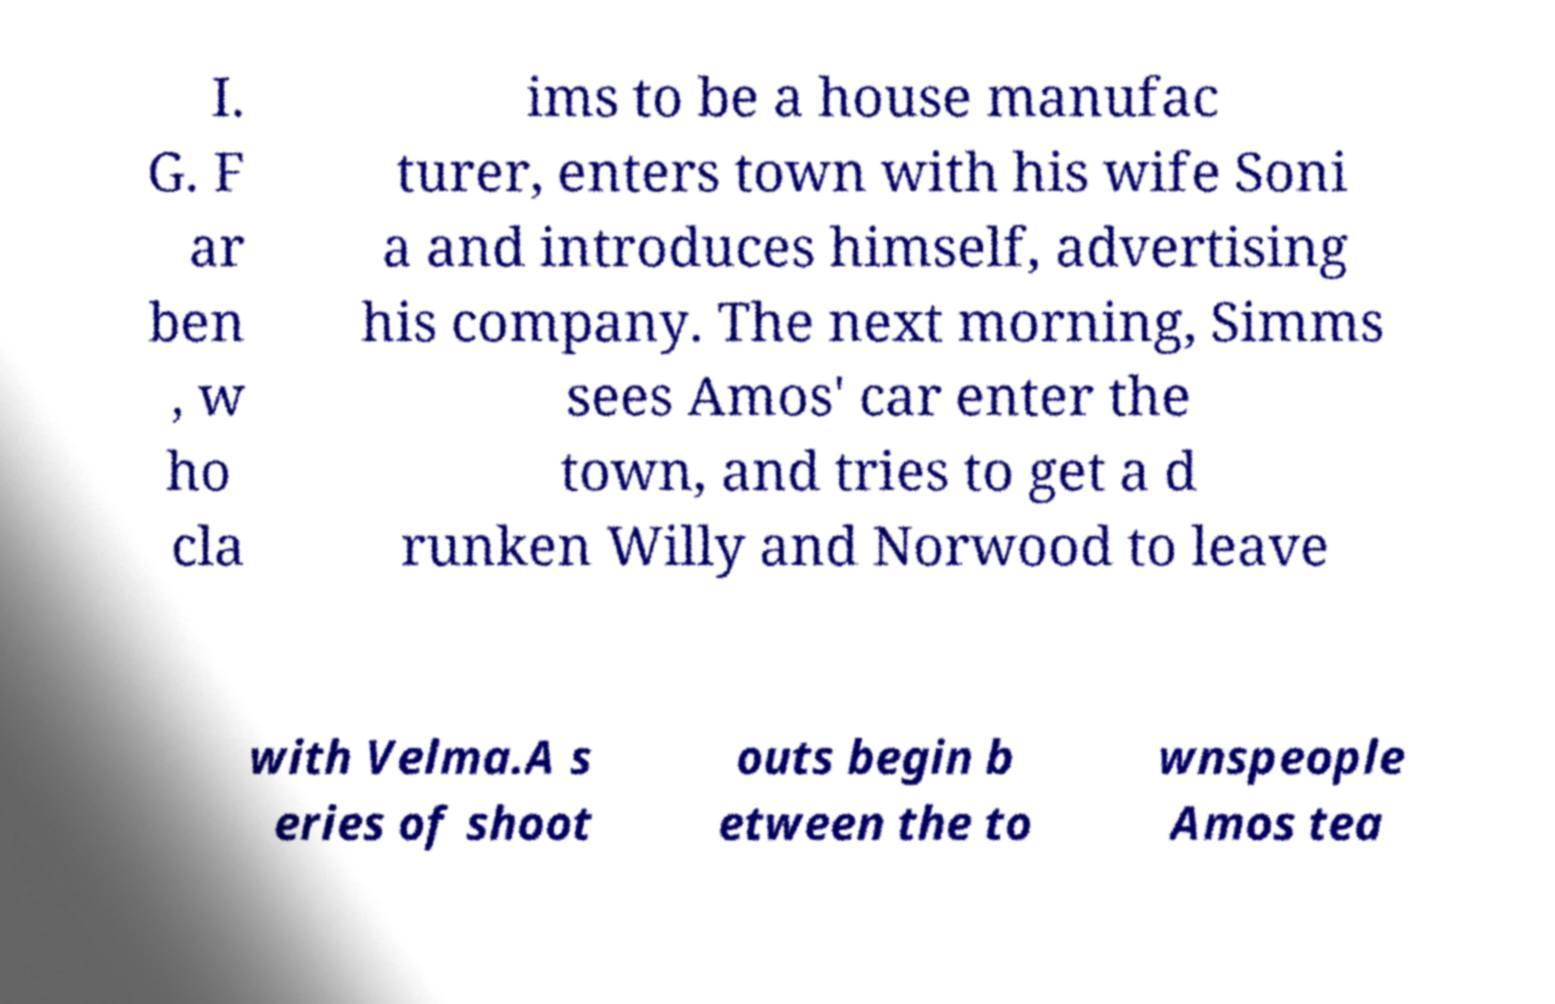Can you accurately transcribe the text from the provided image for me? I. G. F ar ben , w ho cla ims to be a house manufac turer, enters town with his wife Soni a and introduces himself, advertising his company. The next morning, Simms sees Amos' car enter the town, and tries to get a d runken Willy and Norwood to leave with Velma.A s eries of shoot outs begin b etween the to wnspeople Amos tea 